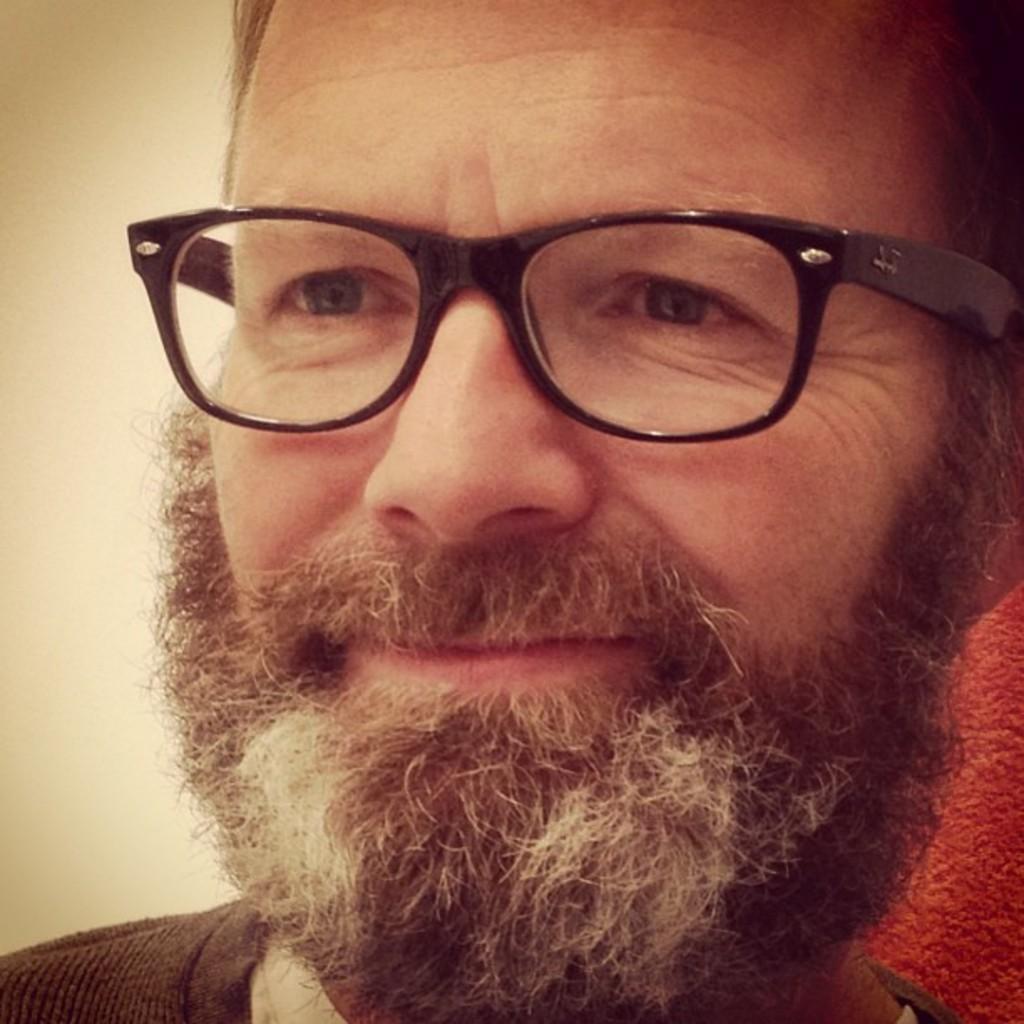In one or two sentences, can you explain what this image depicts? In this picture I can see a man is wearing spectacles. 